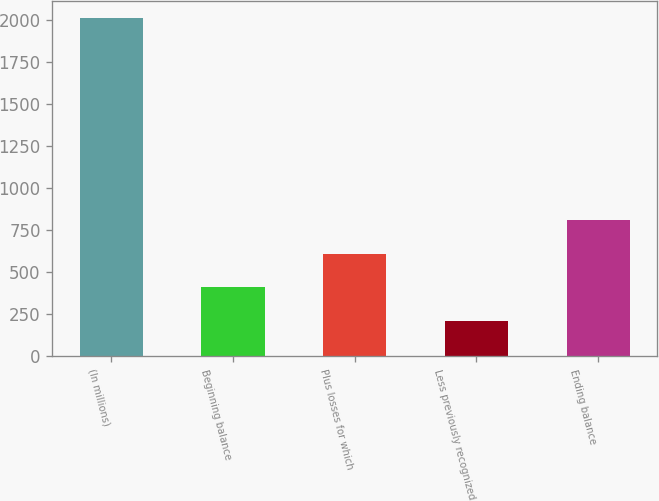<chart> <loc_0><loc_0><loc_500><loc_500><bar_chart><fcel>(In millions)<fcel>Beginning balance<fcel>Plus losses for which<fcel>Less previously recognized<fcel>Ending balance<nl><fcel>2011<fcel>410.2<fcel>610.3<fcel>210.1<fcel>810.4<nl></chart> 